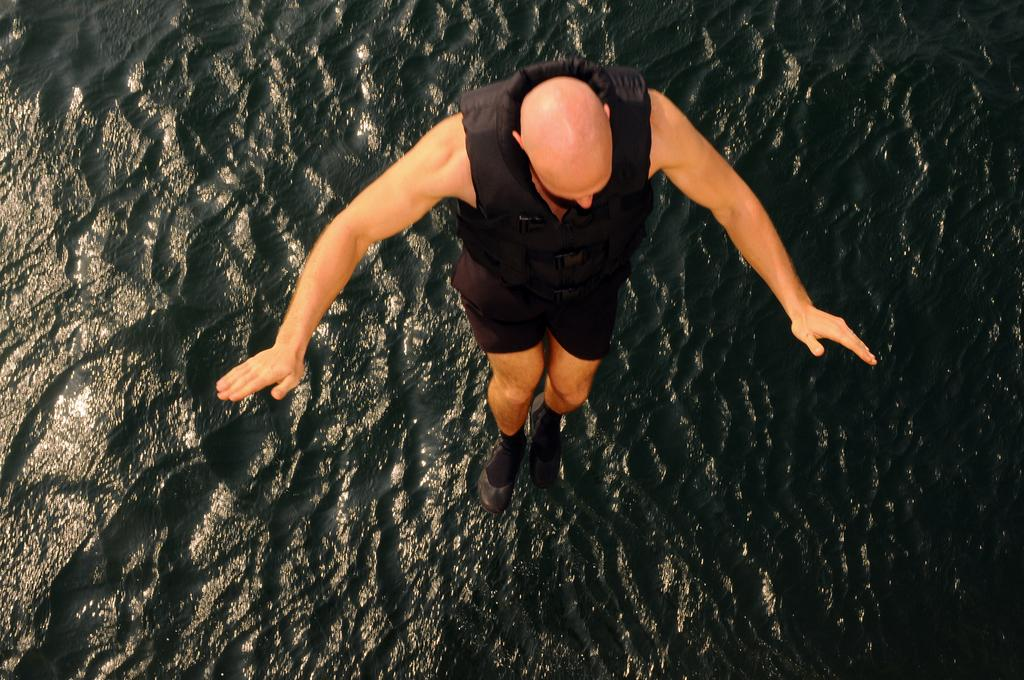Who is the main subject in the image? There is a man in the image. What is the man doing in the image? The man is jumping into the sea. What is the man wearing in the image? The man is wearing a black jacket. What type of environment is visible in the image? There is a sea visible in the image. What type of doctor can be seen in the image? There is no doctor present in the image; it features a man jumping into the sea. Where is the lunchroom located in the image? There is no lunchroom present in the image; it features a man jumping into the sea. 